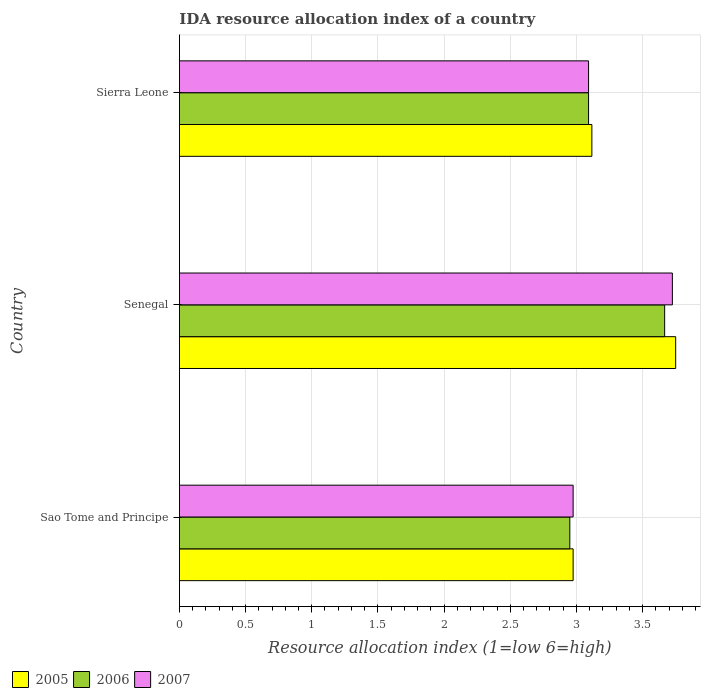Are the number of bars per tick equal to the number of legend labels?
Provide a short and direct response. Yes. Are the number of bars on each tick of the Y-axis equal?
Ensure brevity in your answer.  Yes. How many bars are there on the 2nd tick from the top?
Offer a very short reply. 3. How many bars are there on the 3rd tick from the bottom?
Give a very brief answer. 3. What is the label of the 1st group of bars from the top?
Your answer should be very brief. Sierra Leone. What is the IDA resource allocation index in 2006 in Sao Tome and Principe?
Offer a very short reply. 2.95. Across all countries, what is the maximum IDA resource allocation index in 2006?
Make the answer very short. 3.67. Across all countries, what is the minimum IDA resource allocation index in 2005?
Keep it short and to the point. 2.98. In which country was the IDA resource allocation index in 2006 maximum?
Your answer should be very brief. Senegal. In which country was the IDA resource allocation index in 2005 minimum?
Provide a succinct answer. Sao Tome and Principe. What is the total IDA resource allocation index in 2006 in the graph?
Your answer should be very brief. 9.71. What is the difference between the IDA resource allocation index in 2006 in Senegal and that in Sierra Leone?
Give a very brief answer. 0.58. What is the difference between the IDA resource allocation index in 2006 in Sierra Leone and the IDA resource allocation index in 2007 in Sao Tome and Principe?
Make the answer very short. 0.12. What is the average IDA resource allocation index in 2007 per country?
Your answer should be very brief. 3.26. What is the difference between the IDA resource allocation index in 2005 and IDA resource allocation index in 2007 in Sao Tome and Principe?
Your answer should be very brief. 0. What is the ratio of the IDA resource allocation index in 2006 in Senegal to that in Sierra Leone?
Make the answer very short. 1.19. Is the difference between the IDA resource allocation index in 2005 in Sao Tome and Principe and Sierra Leone greater than the difference between the IDA resource allocation index in 2007 in Sao Tome and Principe and Sierra Leone?
Keep it short and to the point. No. What is the difference between the highest and the second highest IDA resource allocation index in 2007?
Offer a very short reply. 0.63. What is the difference between the highest and the lowest IDA resource allocation index in 2005?
Offer a very short reply. 0.77. Is the sum of the IDA resource allocation index in 2006 in Sao Tome and Principe and Senegal greater than the maximum IDA resource allocation index in 2007 across all countries?
Your answer should be very brief. Yes. What does the 3rd bar from the bottom in Sao Tome and Principe represents?
Your response must be concise. 2007. How many bars are there?
Your response must be concise. 9. Are all the bars in the graph horizontal?
Make the answer very short. Yes. What is the difference between two consecutive major ticks on the X-axis?
Give a very brief answer. 0.5. How many legend labels are there?
Your response must be concise. 3. What is the title of the graph?
Your response must be concise. IDA resource allocation index of a country. What is the label or title of the X-axis?
Keep it short and to the point. Resource allocation index (1=low 6=high). What is the label or title of the Y-axis?
Offer a terse response. Country. What is the Resource allocation index (1=low 6=high) of 2005 in Sao Tome and Principe?
Keep it short and to the point. 2.98. What is the Resource allocation index (1=low 6=high) in 2006 in Sao Tome and Principe?
Offer a terse response. 2.95. What is the Resource allocation index (1=low 6=high) of 2007 in Sao Tome and Principe?
Provide a short and direct response. 2.98. What is the Resource allocation index (1=low 6=high) in 2005 in Senegal?
Provide a succinct answer. 3.75. What is the Resource allocation index (1=low 6=high) of 2006 in Senegal?
Your answer should be very brief. 3.67. What is the Resource allocation index (1=low 6=high) in 2007 in Senegal?
Offer a very short reply. 3.73. What is the Resource allocation index (1=low 6=high) of 2005 in Sierra Leone?
Make the answer very short. 3.12. What is the Resource allocation index (1=low 6=high) of 2006 in Sierra Leone?
Keep it short and to the point. 3.09. What is the Resource allocation index (1=low 6=high) of 2007 in Sierra Leone?
Provide a succinct answer. 3.09. Across all countries, what is the maximum Resource allocation index (1=low 6=high) of 2005?
Give a very brief answer. 3.75. Across all countries, what is the maximum Resource allocation index (1=low 6=high) of 2006?
Give a very brief answer. 3.67. Across all countries, what is the maximum Resource allocation index (1=low 6=high) of 2007?
Give a very brief answer. 3.73. Across all countries, what is the minimum Resource allocation index (1=low 6=high) in 2005?
Offer a very short reply. 2.98. Across all countries, what is the minimum Resource allocation index (1=low 6=high) of 2006?
Give a very brief answer. 2.95. Across all countries, what is the minimum Resource allocation index (1=low 6=high) of 2007?
Keep it short and to the point. 2.98. What is the total Resource allocation index (1=low 6=high) of 2005 in the graph?
Provide a short and direct response. 9.84. What is the total Resource allocation index (1=low 6=high) in 2006 in the graph?
Your answer should be very brief. 9.71. What is the total Resource allocation index (1=low 6=high) in 2007 in the graph?
Provide a short and direct response. 9.79. What is the difference between the Resource allocation index (1=low 6=high) in 2005 in Sao Tome and Principe and that in Senegal?
Make the answer very short. -0.78. What is the difference between the Resource allocation index (1=low 6=high) in 2006 in Sao Tome and Principe and that in Senegal?
Your answer should be compact. -0.72. What is the difference between the Resource allocation index (1=low 6=high) in 2007 in Sao Tome and Principe and that in Senegal?
Keep it short and to the point. -0.75. What is the difference between the Resource allocation index (1=low 6=high) of 2005 in Sao Tome and Principe and that in Sierra Leone?
Give a very brief answer. -0.14. What is the difference between the Resource allocation index (1=low 6=high) in 2006 in Sao Tome and Principe and that in Sierra Leone?
Your answer should be very brief. -0.14. What is the difference between the Resource allocation index (1=low 6=high) of 2007 in Sao Tome and Principe and that in Sierra Leone?
Offer a very short reply. -0.12. What is the difference between the Resource allocation index (1=low 6=high) in 2005 in Senegal and that in Sierra Leone?
Make the answer very short. 0.63. What is the difference between the Resource allocation index (1=low 6=high) in 2006 in Senegal and that in Sierra Leone?
Your response must be concise. 0.57. What is the difference between the Resource allocation index (1=low 6=high) in 2007 in Senegal and that in Sierra Leone?
Provide a succinct answer. 0.63. What is the difference between the Resource allocation index (1=low 6=high) in 2005 in Sao Tome and Principe and the Resource allocation index (1=low 6=high) in 2006 in Senegal?
Provide a succinct answer. -0.69. What is the difference between the Resource allocation index (1=low 6=high) of 2005 in Sao Tome and Principe and the Resource allocation index (1=low 6=high) of 2007 in Senegal?
Ensure brevity in your answer.  -0.75. What is the difference between the Resource allocation index (1=low 6=high) in 2006 in Sao Tome and Principe and the Resource allocation index (1=low 6=high) in 2007 in Senegal?
Your answer should be very brief. -0.78. What is the difference between the Resource allocation index (1=low 6=high) of 2005 in Sao Tome and Principe and the Resource allocation index (1=low 6=high) of 2006 in Sierra Leone?
Ensure brevity in your answer.  -0.12. What is the difference between the Resource allocation index (1=low 6=high) of 2005 in Sao Tome and Principe and the Resource allocation index (1=low 6=high) of 2007 in Sierra Leone?
Your answer should be compact. -0.12. What is the difference between the Resource allocation index (1=low 6=high) in 2006 in Sao Tome and Principe and the Resource allocation index (1=low 6=high) in 2007 in Sierra Leone?
Your answer should be very brief. -0.14. What is the difference between the Resource allocation index (1=low 6=high) of 2005 in Senegal and the Resource allocation index (1=low 6=high) of 2006 in Sierra Leone?
Your response must be concise. 0.66. What is the difference between the Resource allocation index (1=low 6=high) in 2005 in Senegal and the Resource allocation index (1=low 6=high) in 2007 in Sierra Leone?
Ensure brevity in your answer.  0.66. What is the difference between the Resource allocation index (1=low 6=high) in 2006 in Senegal and the Resource allocation index (1=low 6=high) in 2007 in Sierra Leone?
Offer a terse response. 0.57. What is the average Resource allocation index (1=low 6=high) in 2005 per country?
Give a very brief answer. 3.28. What is the average Resource allocation index (1=low 6=high) in 2006 per country?
Offer a very short reply. 3.24. What is the average Resource allocation index (1=low 6=high) of 2007 per country?
Offer a terse response. 3.26. What is the difference between the Resource allocation index (1=low 6=high) of 2005 and Resource allocation index (1=low 6=high) of 2006 in Sao Tome and Principe?
Provide a succinct answer. 0.03. What is the difference between the Resource allocation index (1=low 6=high) of 2005 and Resource allocation index (1=low 6=high) of 2007 in Sao Tome and Principe?
Ensure brevity in your answer.  0. What is the difference between the Resource allocation index (1=low 6=high) of 2006 and Resource allocation index (1=low 6=high) of 2007 in Sao Tome and Principe?
Your answer should be very brief. -0.03. What is the difference between the Resource allocation index (1=low 6=high) of 2005 and Resource allocation index (1=low 6=high) of 2006 in Senegal?
Your answer should be compact. 0.08. What is the difference between the Resource allocation index (1=low 6=high) of 2005 and Resource allocation index (1=low 6=high) of 2007 in Senegal?
Offer a very short reply. 0.03. What is the difference between the Resource allocation index (1=low 6=high) of 2006 and Resource allocation index (1=low 6=high) of 2007 in Senegal?
Offer a very short reply. -0.06. What is the difference between the Resource allocation index (1=low 6=high) in 2005 and Resource allocation index (1=low 6=high) in 2006 in Sierra Leone?
Offer a very short reply. 0.03. What is the difference between the Resource allocation index (1=low 6=high) in 2005 and Resource allocation index (1=low 6=high) in 2007 in Sierra Leone?
Provide a succinct answer. 0.03. What is the ratio of the Resource allocation index (1=low 6=high) of 2005 in Sao Tome and Principe to that in Senegal?
Your response must be concise. 0.79. What is the ratio of the Resource allocation index (1=low 6=high) in 2006 in Sao Tome and Principe to that in Senegal?
Provide a succinct answer. 0.8. What is the ratio of the Resource allocation index (1=low 6=high) in 2007 in Sao Tome and Principe to that in Senegal?
Give a very brief answer. 0.8. What is the ratio of the Resource allocation index (1=low 6=high) in 2005 in Sao Tome and Principe to that in Sierra Leone?
Your answer should be very brief. 0.95. What is the ratio of the Resource allocation index (1=low 6=high) of 2006 in Sao Tome and Principe to that in Sierra Leone?
Offer a very short reply. 0.95. What is the ratio of the Resource allocation index (1=low 6=high) of 2007 in Sao Tome and Principe to that in Sierra Leone?
Offer a terse response. 0.96. What is the ratio of the Resource allocation index (1=low 6=high) of 2005 in Senegal to that in Sierra Leone?
Your answer should be compact. 1.2. What is the ratio of the Resource allocation index (1=low 6=high) in 2006 in Senegal to that in Sierra Leone?
Offer a very short reply. 1.19. What is the ratio of the Resource allocation index (1=low 6=high) of 2007 in Senegal to that in Sierra Leone?
Provide a succinct answer. 1.2. What is the difference between the highest and the second highest Resource allocation index (1=low 6=high) of 2005?
Provide a succinct answer. 0.63. What is the difference between the highest and the second highest Resource allocation index (1=low 6=high) of 2006?
Keep it short and to the point. 0.57. What is the difference between the highest and the second highest Resource allocation index (1=low 6=high) of 2007?
Provide a succinct answer. 0.63. What is the difference between the highest and the lowest Resource allocation index (1=low 6=high) of 2005?
Give a very brief answer. 0.78. What is the difference between the highest and the lowest Resource allocation index (1=low 6=high) of 2006?
Give a very brief answer. 0.72. 